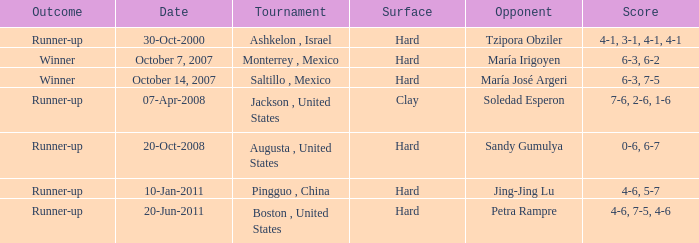Would you be able to parse every entry in this table? {'header': ['Outcome', 'Date', 'Tournament', 'Surface', 'Opponent', 'Score'], 'rows': [['Runner-up', '30-Oct-2000', 'Ashkelon , Israel', 'Hard', 'Tzipora Obziler', '4-1, 3-1, 4-1, 4-1'], ['Winner', 'October 7, 2007', 'Monterrey , Mexico', 'Hard', 'María Irigoyen', '6-3, 6-2'], ['Winner', 'October 14, 2007', 'Saltillo , Mexico', 'Hard', 'María José Argeri', '6-3, 7-5'], ['Runner-up', '07-Apr-2008', 'Jackson , United States', 'Clay', 'Soledad Esperon', '7-6, 2-6, 1-6'], ['Runner-up', '20-Oct-2008', 'Augusta , United States', 'Hard', 'Sandy Gumulya', '0-6, 6-7'], ['Runner-up', '10-Jan-2011', 'Pingguo , China', 'Hard', 'Jing-Jing Lu', '4-6, 5-7'], ['Runner-up', '20-Jun-2011', 'Boston , United States', 'Hard', 'Petra Rampre', '4-6, 7-5, 4-6']]} Which contest occurred on october 14, 2007? Saltillo , Mexico. 